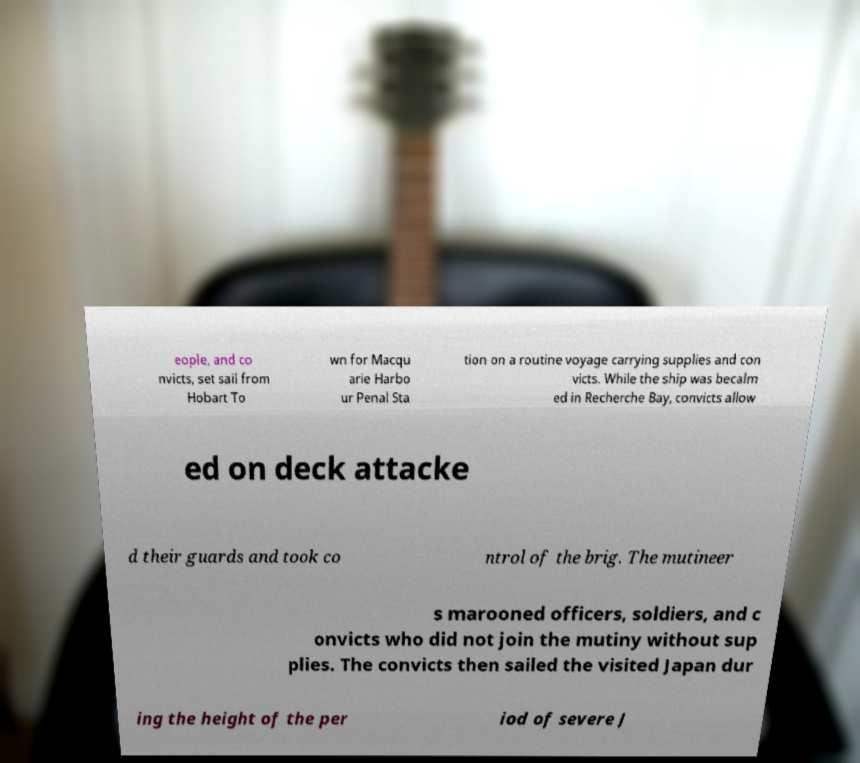Please identify and transcribe the text found in this image. eople, and co nvicts, set sail from Hobart To wn for Macqu arie Harbo ur Penal Sta tion on a routine voyage carrying supplies and con victs. While the ship was becalm ed in Recherche Bay, convicts allow ed on deck attacke d their guards and took co ntrol of the brig. The mutineer s marooned officers, soldiers, and c onvicts who did not join the mutiny without sup plies. The convicts then sailed the visited Japan dur ing the height of the per iod of severe J 